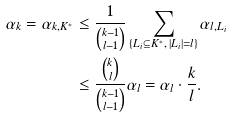Convert formula to latex. <formula><loc_0><loc_0><loc_500><loc_500>\alpha _ { k } = \alpha _ { k , K ^ { * } } & \leq \frac { 1 } { \binom { k - 1 } { l - 1 } } \sum _ { \{ L _ { i } \subseteq K ^ { * } , \, | L _ { i } | = l \} } \alpha _ { l , L _ { i } } \\ & \leq \frac { \binom { k } { l } } { \binom { k - 1 } { l - 1 } } \alpha _ { l } = \alpha _ { l } \cdot \frac { k } { l } .</formula> 